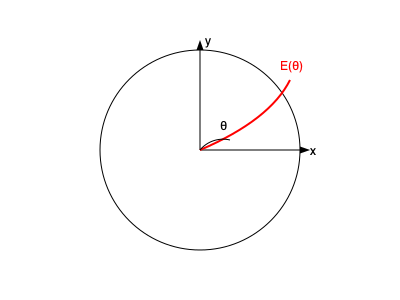Given the antenna radiation pattern $E(\theta)$ shown in the figure, which represents the electric field intensity as a function of the elevation angle $\theta$, how would you determine if this antenna complies with FCC regulations that limit the maximum power density in any direction to 1 mW/cm² at a distance of 3 meters? Assume the antenna input power is 100 W and operates at 2.4 GHz. To determine FCC compliance, we need to follow these steps:

1) First, we need to understand that the power density $S$ at a distance $r$ from the antenna is related to the electric field intensity $E$ by:

   $$S = \frac{|E|^2}{120\pi}$$

2) The FCC limit is given in terms of power density, so we need to calculate the maximum power density at 3 meters.

3) The maximum power density will occur in the direction of maximum radiation, which corresponds to the peak of $E(\theta)$ in the diagram.

4) To find the electric field intensity at 3 meters, we use the formula:

   $$E = \sqrt{\frac{30P_tG_t}{r^2}}$$

   Where $P_t$ is the transmit power (100 W), $G_t$ is the antenna gain, and $r$ is the distance (3 m).

5) We need to determine the antenna gain $G_t$. This is related to the directivity $D$ by:

   $$G_t = \eta D$$

   Where $\eta$ is the antenna efficiency (typically 0.6-0.9 for most antennas).

6) The directivity can be estimated from the radiation pattern. A rough estimate can be made by comparing the main lobe width to that of an isotropic antenna.

7) Once we have $G_t$, we can calculate $E$ at 3 meters, then calculate $S$ using the formula from step 1.

8) Finally, we compare the calculated $S$ to the FCC limit of 1 mW/cm².

9) If the calculated $S$ is less than or equal to 1 mW/cm², the antenna complies with FCC regulations. If it's greater, it does not comply.
Answer: Calculate maximum power density at 3m using $S = \frac{|E|^2}{120\pi}$, where $E = \sqrt{\frac{30P_tG_t}{r^2}}$, and compare to 1 mW/cm² FCC limit. 